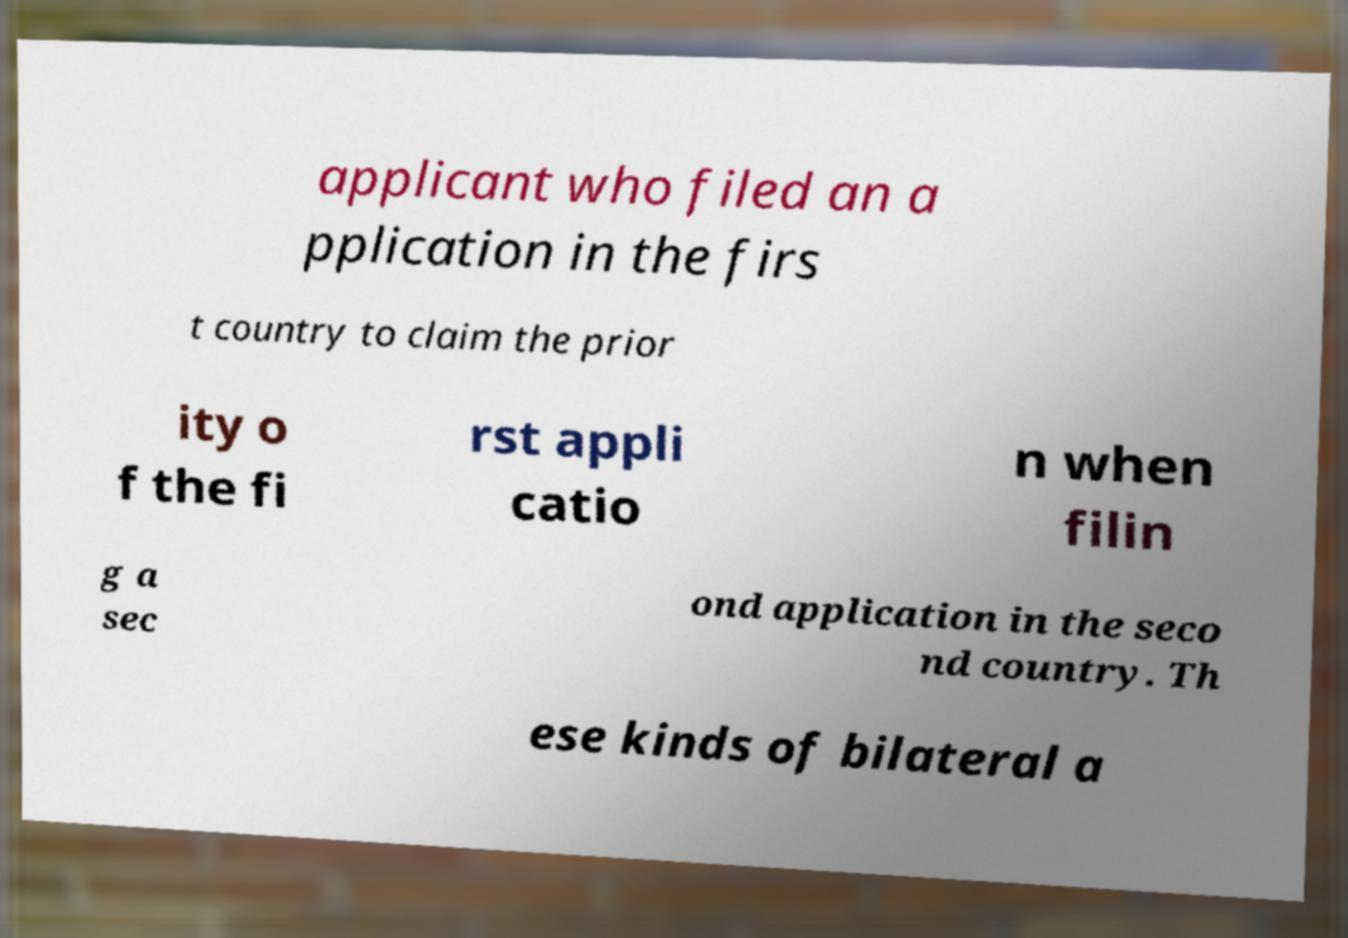Could you assist in decoding the text presented in this image and type it out clearly? applicant who filed an a pplication in the firs t country to claim the prior ity o f the fi rst appli catio n when filin g a sec ond application in the seco nd country. Th ese kinds of bilateral a 